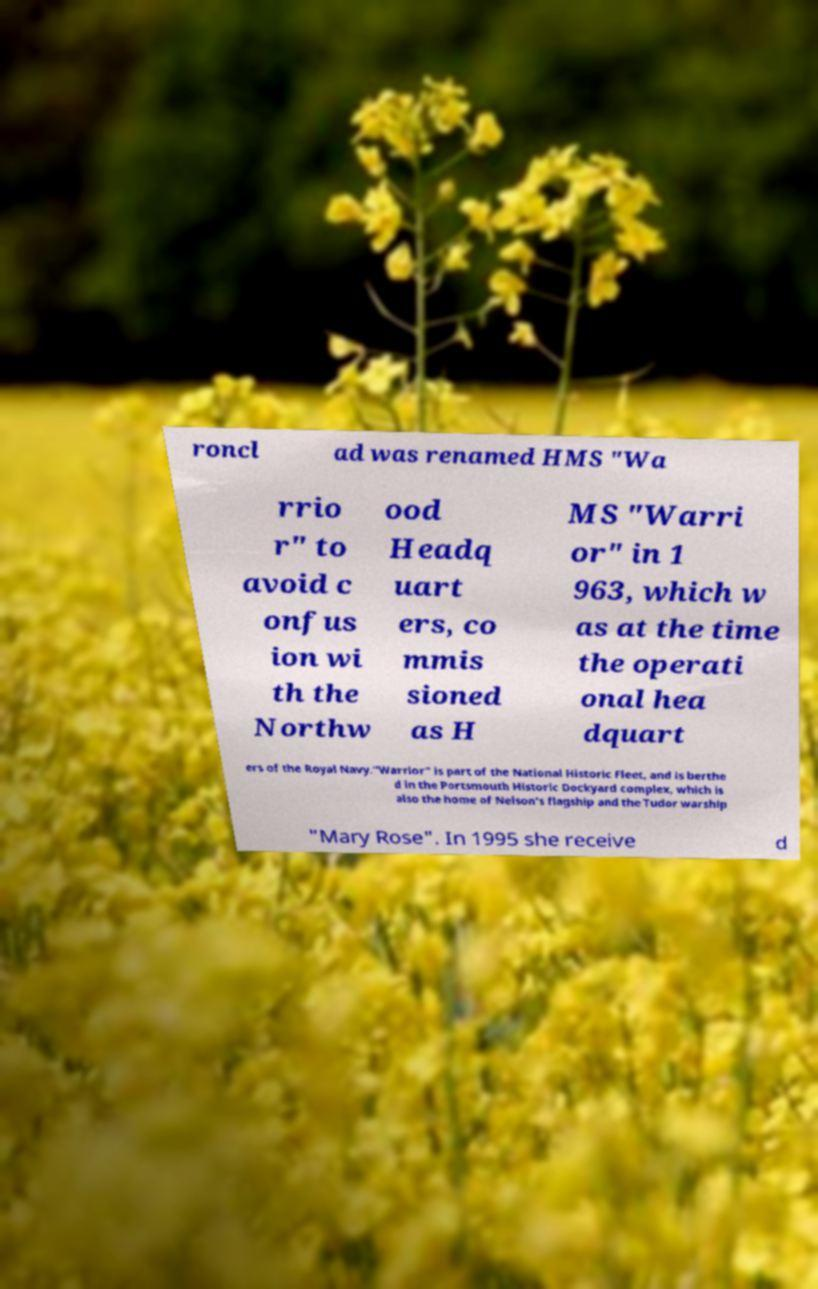Please read and relay the text visible in this image. What does it say? roncl ad was renamed HMS "Wa rrio r" to avoid c onfus ion wi th the Northw ood Headq uart ers, co mmis sioned as H MS "Warri or" in 1 963, which w as at the time the operati onal hea dquart ers of the Royal Navy."Warrior" is part of the National Historic Fleet, and is berthe d in the Portsmouth Historic Dockyard complex, which is also the home of Nelson's flagship and the Tudor warship "Mary Rose". In 1995 she receive d 